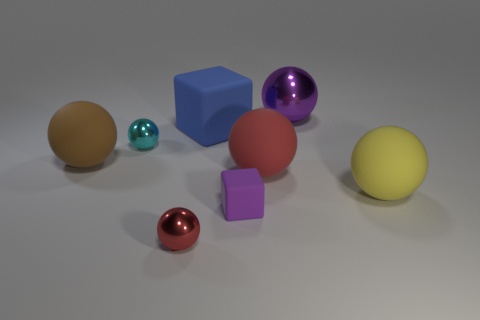Subtract all large yellow spheres. How many spheres are left? 5 Subtract all brown balls. How many balls are left? 5 Subtract all brown balls. Subtract all cyan cylinders. How many balls are left? 5 Add 1 large cyan cubes. How many objects exist? 9 Subtract all blocks. How many objects are left? 6 Subtract all small purple rubber spheres. Subtract all large red matte objects. How many objects are left? 7 Add 1 small matte blocks. How many small matte blocks are left? 2 Add 7 tiny cyan things. How many tiny cyan things exist? 8 Subtract 1 blue blocks. How many objects are left? 7 